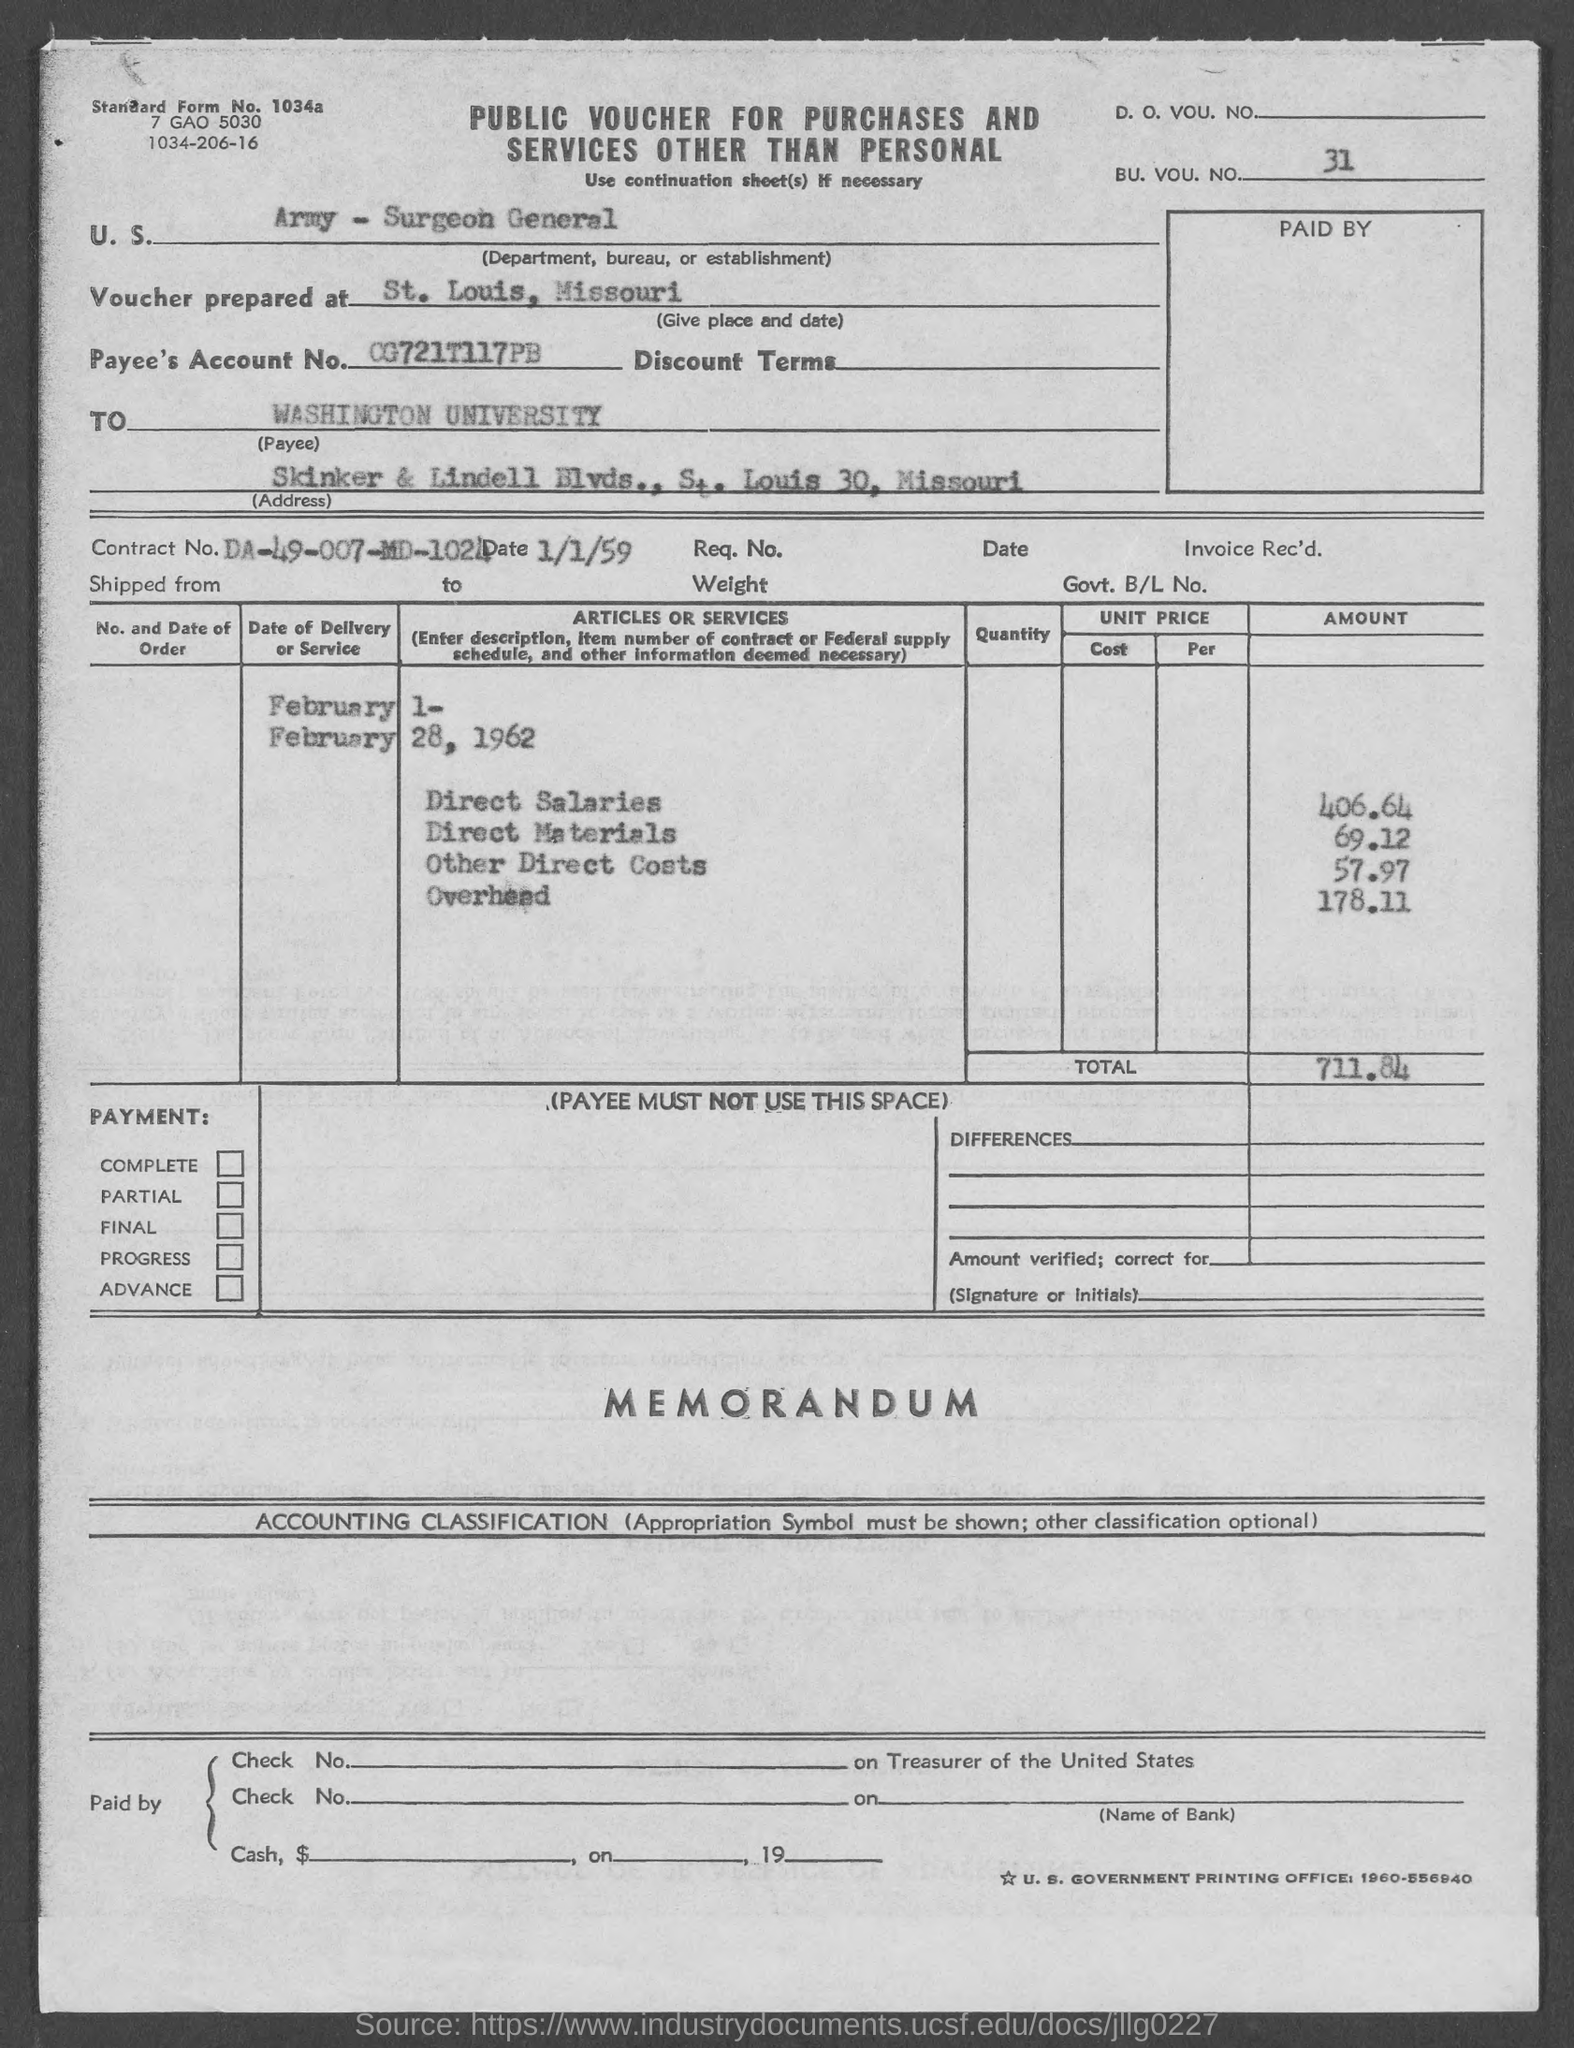Mention a couple of crucial points in this snapshot. The voucher was prepared in St. Louis, Missouri. The payee is named Washington University. 